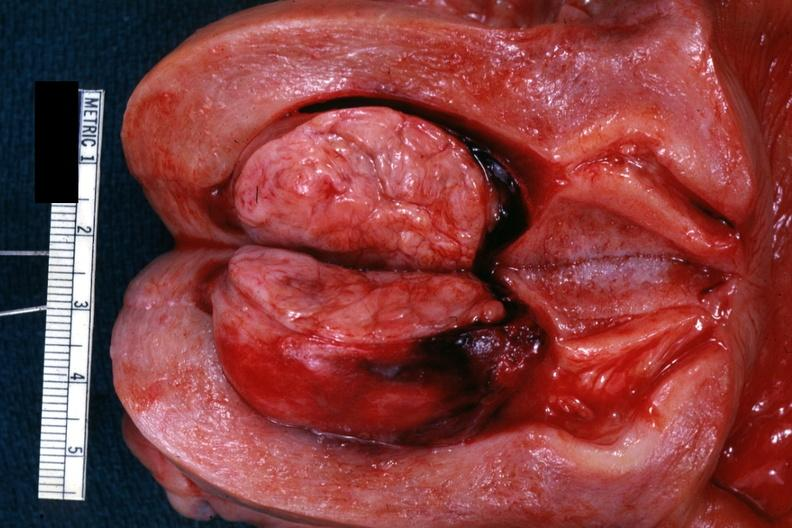s amyloidosis present?
Answer the question using a single word or phrase. No 